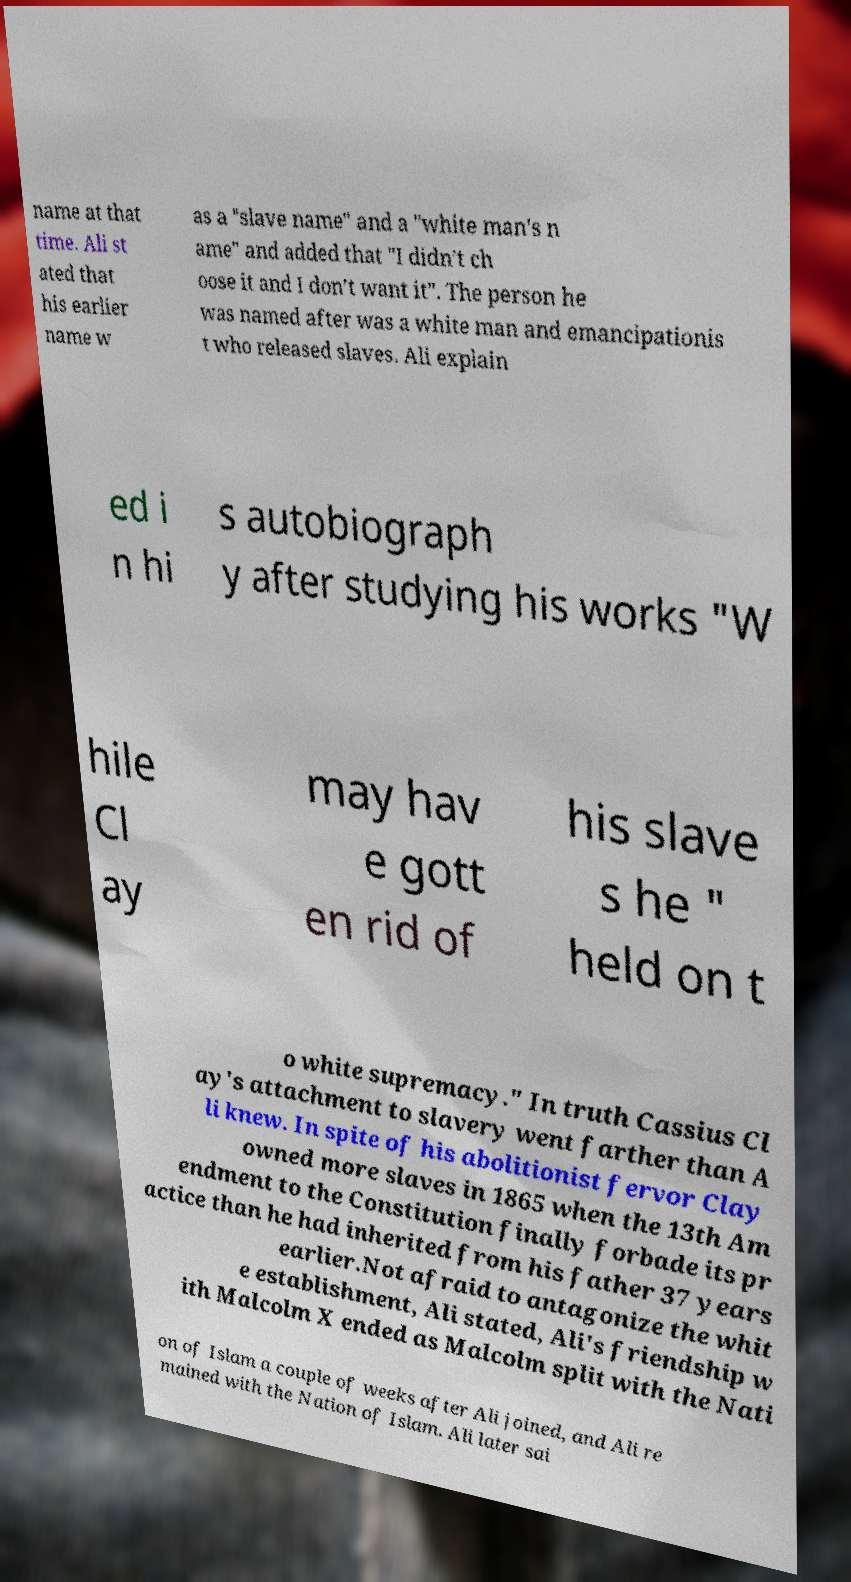There's text embedded in this image that I need extracted. Can you transcribe it verbatim? name at that time. Ali st ated that his earlier name w as a "slave name" and a "white man's n ame" and added that "I didn’t ch oose it and I don’t want it". The person he was named after was a white man and emancipationis t who released slaves. Ali explain ed i n hi s autobiograph y after studying his works "W hile Cl ay may hav e gott en rid of his slave s he " held on t o white supremacy." In truth Cassius Cl ay's attachment to slavery went farther than A li knew. In spite of his abolitionist fervor Clay owned more slaves in 1865 when the 13th Am endment to the Constitution finally forbade its pr actice than he had inherited from his father 37 years earlier.Not afraid to antagonize the whit e establishment, Ali stated, Ali's friendship w ith Malcolm X ended as Malcolm split with the Nati on of Islam a couple of weeks after Ali joined, and Ali re mained with the Nation of Islam. Ali later sai 